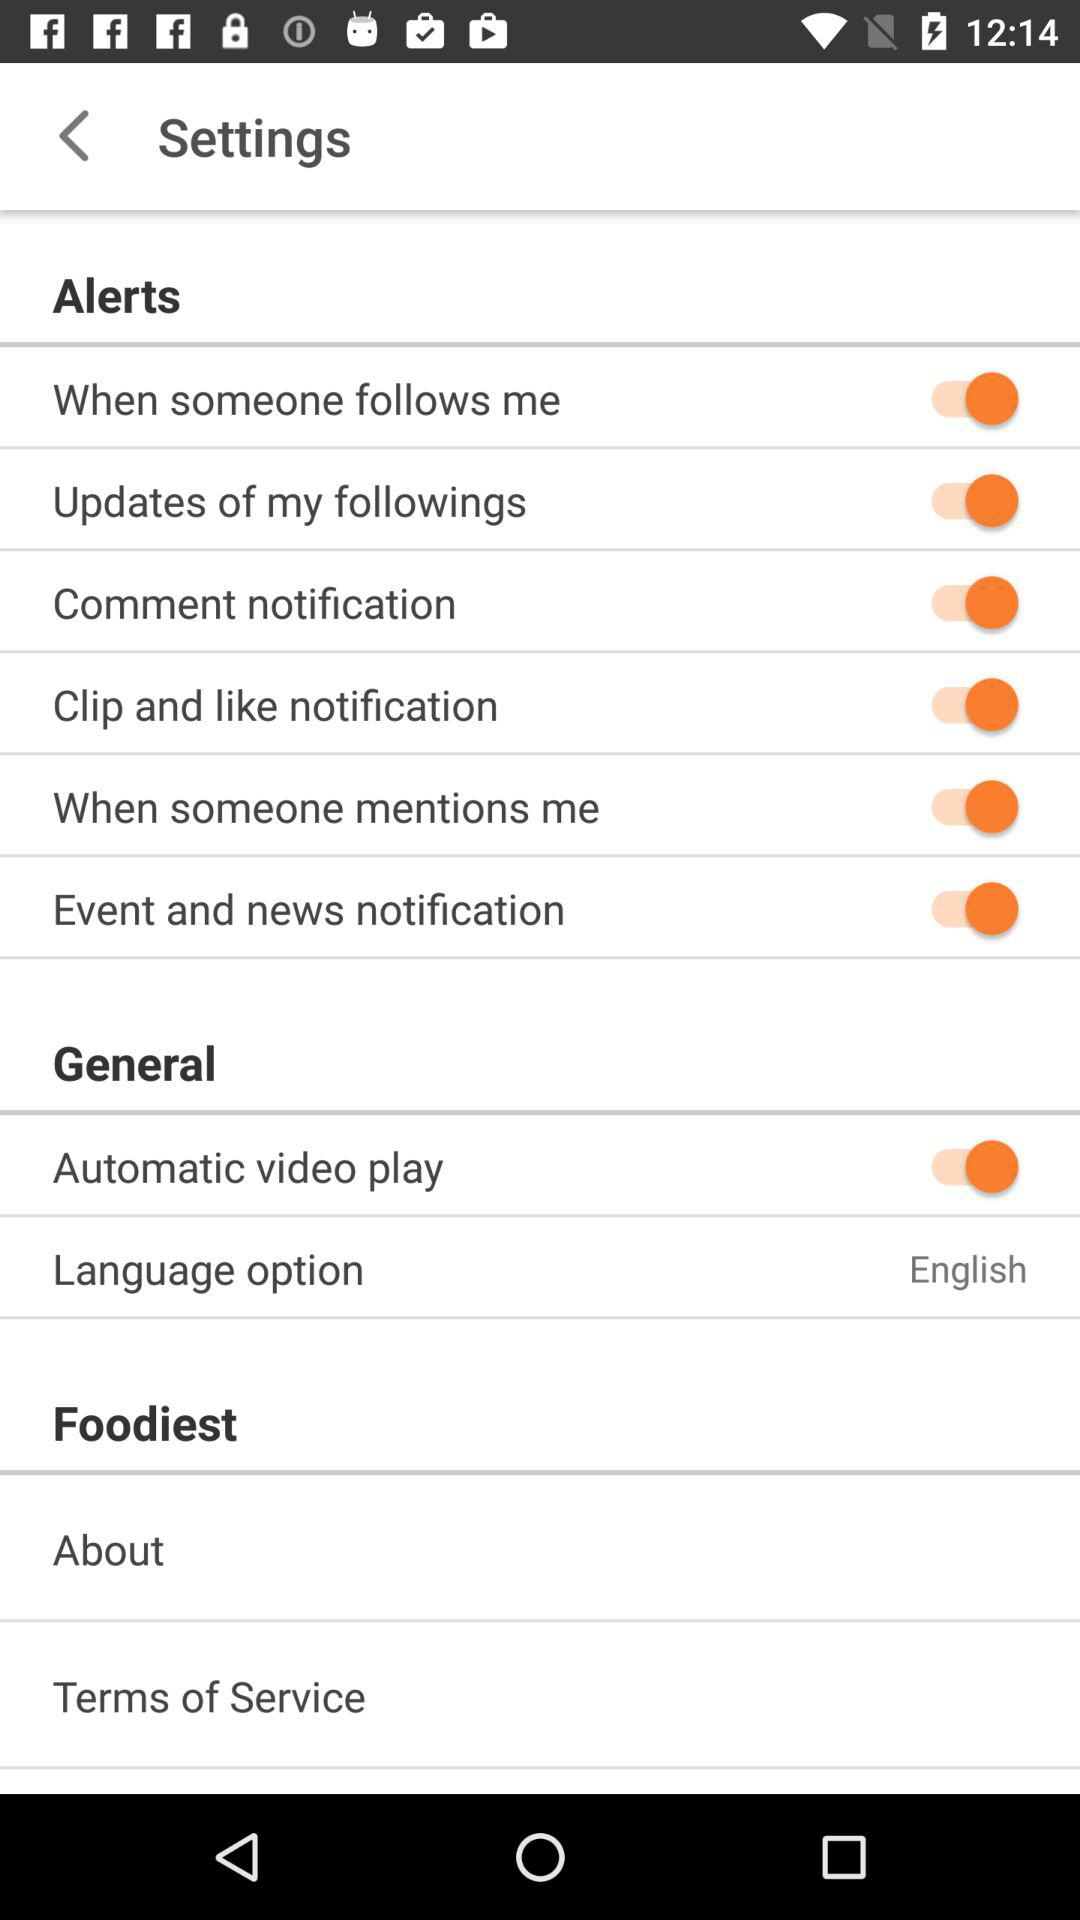What is the status of "Automatic video play"? The status is "on". 